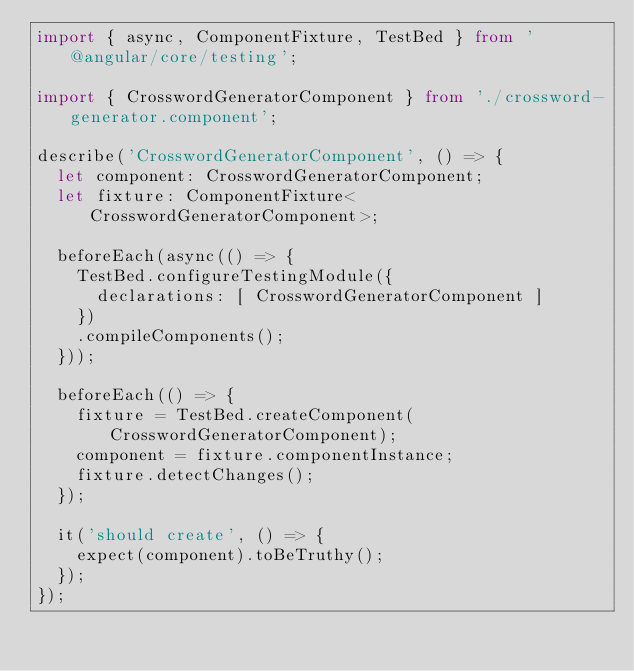Convert code to text. <code><loc_0><loc_0><loc_500><loc_500><_TypeScript_>import { async, ComponentFixture, TestBed } from '@angular/core/testing';

import { CrosswordGeneratorComponent } from './crossword-generator.component';

describe('CrosswordGeneratorComponent', () => {
  let component: CrosswordGeneratorComponent;
  let fixture: ComponentFixture<CrosswordGeneratorComponent>;

  beforeEach(async(() => {
    TestBed.configureTestingModule({
      declarations: [ CrosswordGeneratorComponent ]
    })
    .compileComponents();
  }));

  beforeEach(() => {
    fixture = TestBed.createComponent(CrosswordGeneratorComponent);
    component = fixture.componentInstance;
    fixture.detectChanges();
  });

  it('should create', () => {
    expect(component).toBeTruthy();
  });
});
</code> 